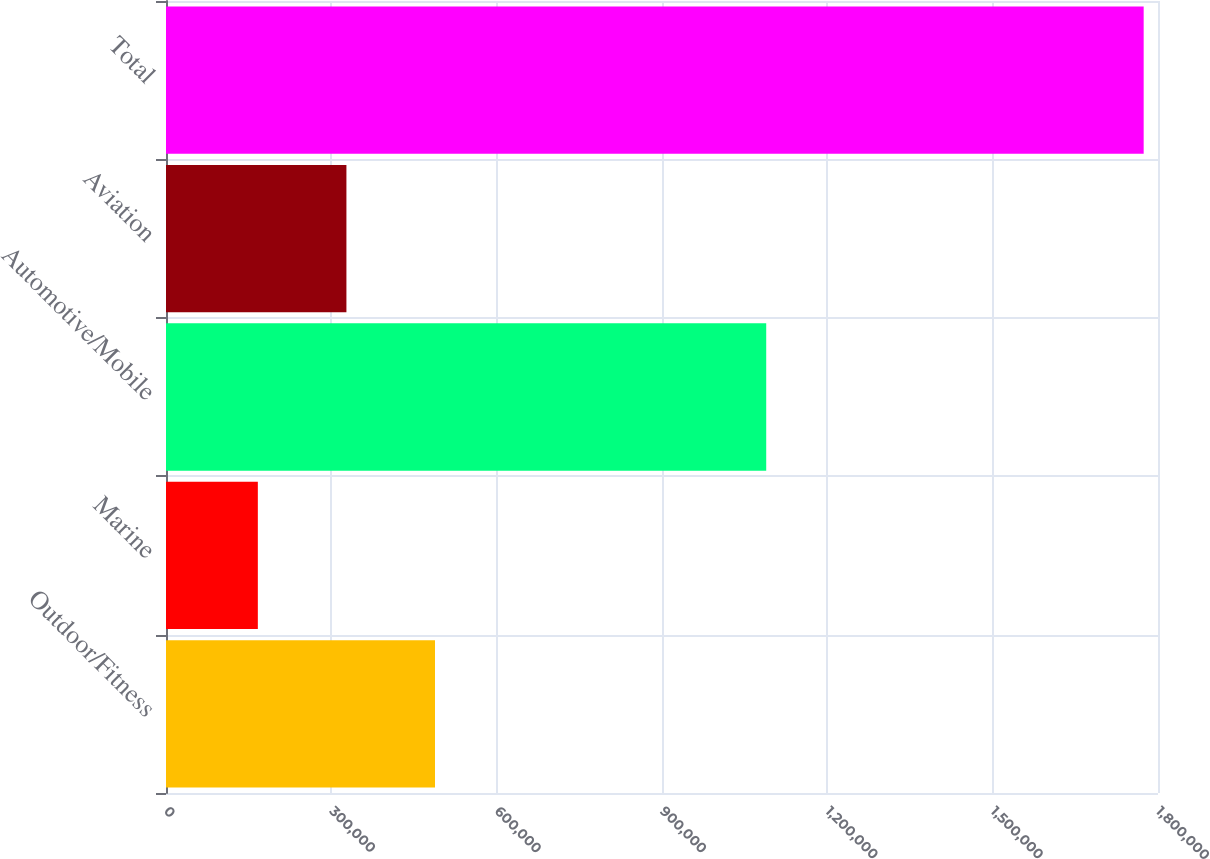Convert chart. <chart><loc_0><loc_0><loc_500><loc_500><bar_chart><fcel>Outdoor/Fitness<fcel>Marine<fcel>Automotive/Mobile<fcel>Aviation<fcel>Total<nl><fcel>488111<fcel>166639<fcel>1.08909e+06<fcel>327375<fcel>1.774e+06<nl></chart> 